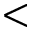Convert formula to latex. <formula><loc_0><loc_0><loc_500><loc_500><</formula> 